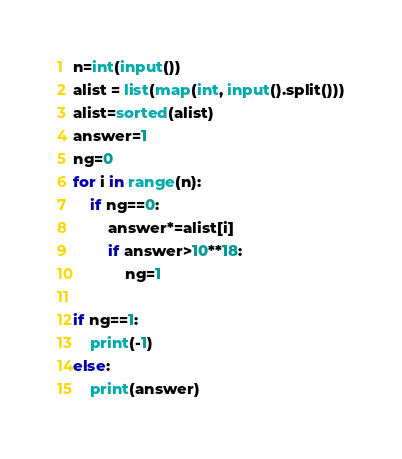Convert code to text. <code><loc_0><loc_0><loc_500><loc_500><_Python_>n=int(input())
alist = list(map(int, input().split()))
alist=sorted(alist)
answer=1
ng=0
for i in range(n):
    if ng==0:
        answer*=alist[i]
        if answer>10**18:
            ng=1

if ng==1:
    print(-1)
else:
    print(answer)</code> 